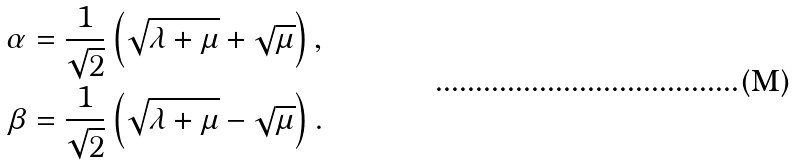Convert formula to latex. <formula><loc_0><loc_0><loc_500><loc_500>\alpha & = \frac { 1 } { \sqrt { 2 } } \left ( \sqrt { \lambda + \mu } + \sqrt { \mu } \right ) , \\ \beta & = \frac { 1 } { \sqrt { 2 } } \left ( \sqrt { \lambda + \mu } - \sqrt { \mu } \right ) .</formula> 